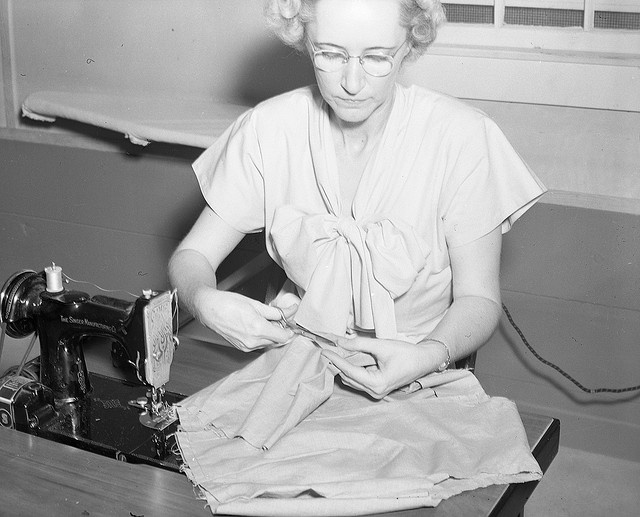Describe the objects in this image and their specific colors. I can see people in darkgray, lightgray, gray, and black tones and scissors in darkgray, gray, lightgray, and black tones in this image. 